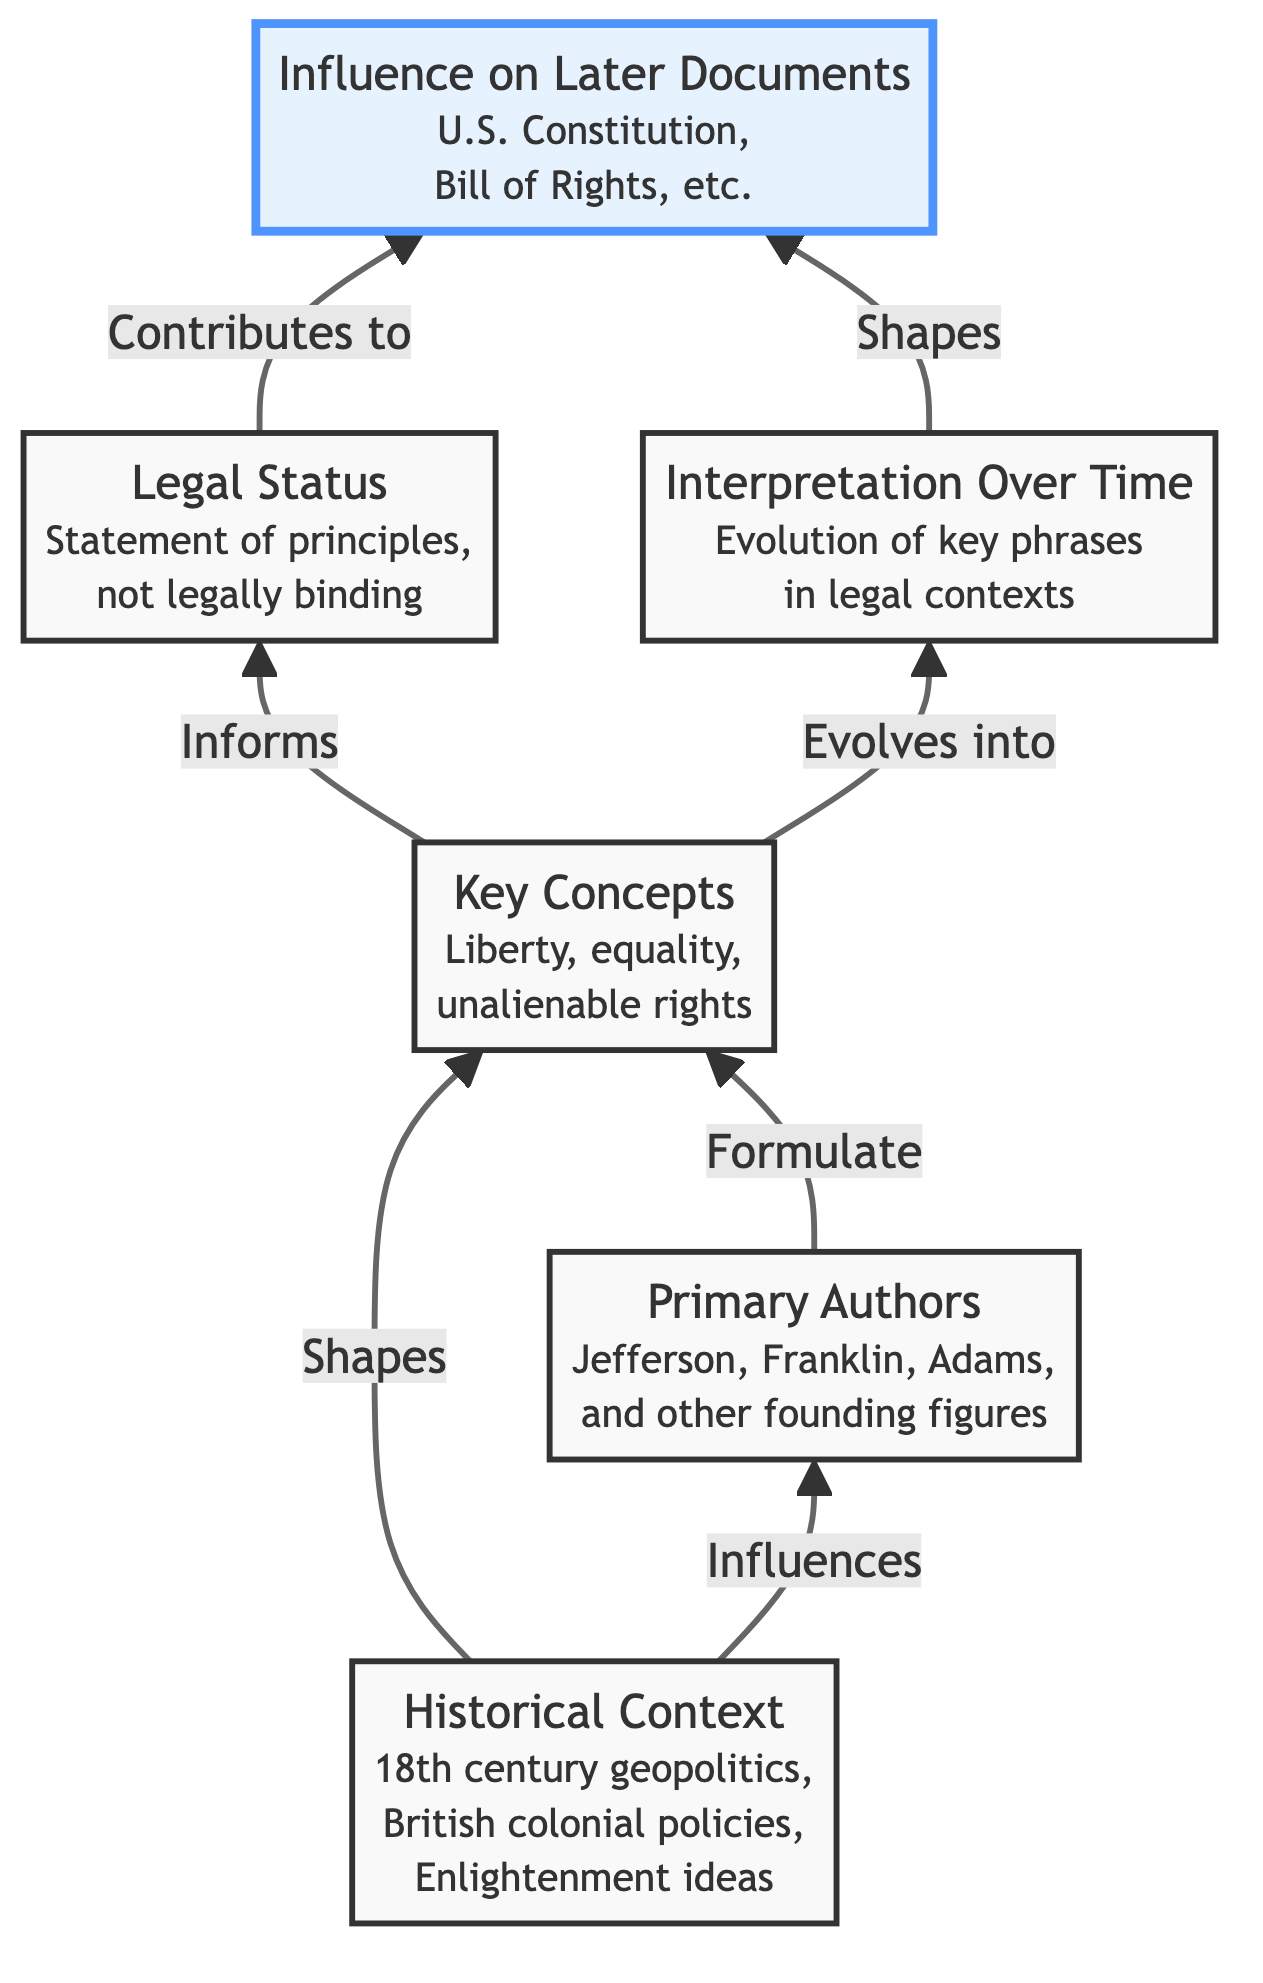What is the first node in the diagram? The first node in the diagram is titled "Historical Context", as it is the starting point from which various influences branch out in the flow chart.
Answer: Historical Context How many key concepts are listed in the diagram? The diagram lists three key concepts: liberty, equality, and unalienable rights. This can be identified in the "Key Concepts" node where these terms are mentioned.
Answer: Three What influences the "Primary Authors" node? The "Historical Context" node influences the "Primary Authors" node, indicating that the geopolitical climate and ideas of the 18th century informed who contributed to the document.
Answer: Historical Context Which node informs the "Legal Status" node? The "Key Concepts" node informs the "Legal Status" node, showing that the principles articulated in the document influence how its legal standing is understood.
Answer: Key Concepts What evolves into "Interpretation Over Time"? The "Key Concepts" node evolves into the "Interpretation Over Time" node, indicating that the understanding of these concepts changes over time.
Answer: Key Concepts What does the "Legal Status" contribute to? The "Legal Status" contributes to the "Influence on Later Documents" node, demonstrating that the principles declared in the Declaration shaped subsequent legal frameworks in America.
Answer: Influence on Later Documents Which two nodes are connected by an edge representing a contribution? The "Legal Status" and "Influence on Later Documents" nodes are connected by an edge that signifies that the former contributes to the latter. This reflects the influence of the Declaration's legal status on later documents.
Answer: Legal Status and Influence on Later Documents How does "Interpretation Over Time" shape the diagram? "Interpretation Over Time" shapes the "Influence on Later Documents" node, indicating that the evolving meanings of phrases affect later legal documents.
Answer: Influence on Later Documents What role does "Influence on Later Documents" play in relation to the chart? The "Influence on Later Documents" node is a terminal point in the diagram, representing the culmination of the influences and interpretations that arose from earlier elements. Its role signifies the lasting impact of the Declaration.
Answer: Terminal point 